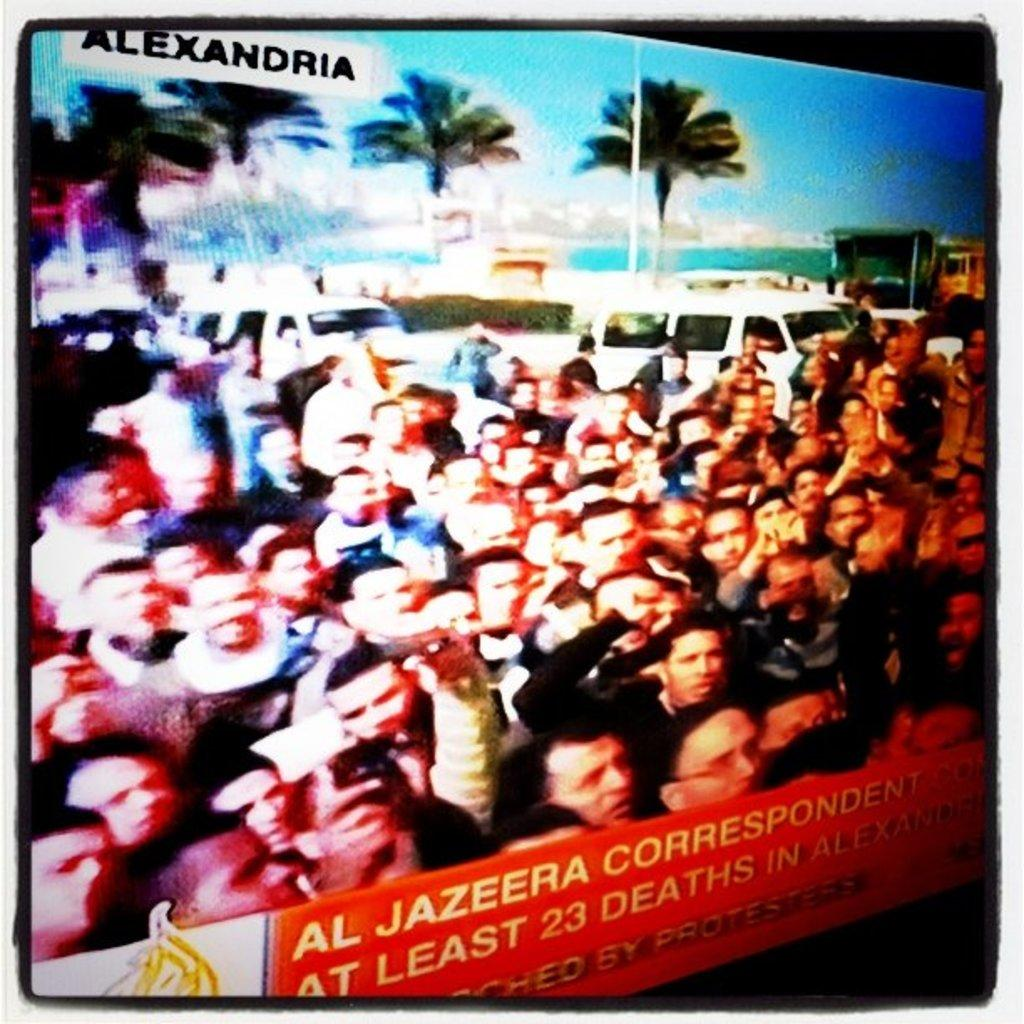<image>
Provide a brief description of the given image. A lot of protesters gathered in Alexandria on Al Jazeera 